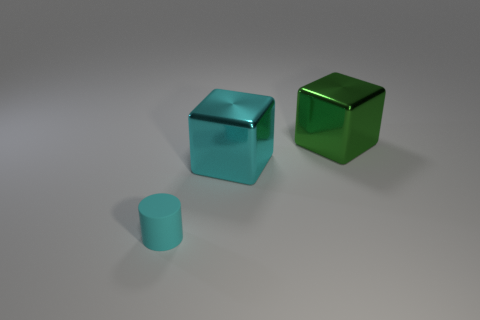Add 3 red objects. How many objects exist? 6 Subtract all cylinders. How many objects are left? 2 Add 3 tiny cyan matte cylinders. How many tiny cyan matte cylinders exist? 4 Subtract 0 red balls. How many objects are left? 3 Subtract all cyan shiny things. Subtract all cubes. How many objects are left? 0 Add 1 tiny cyan matte things. How many tiny cyan matte things are left? 2 